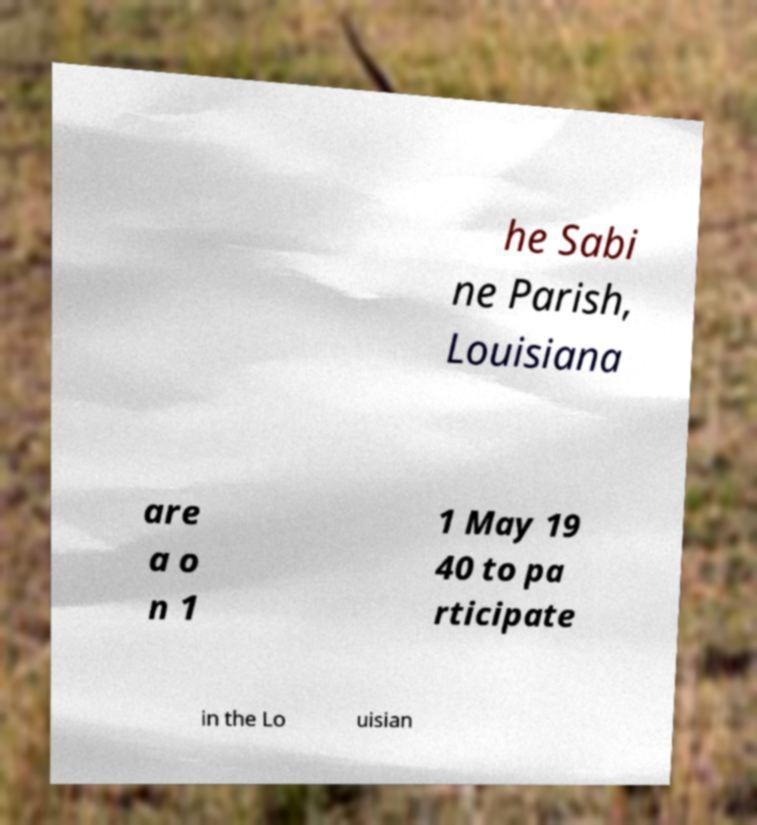Please identify and transcribe the text found in this image. he Sabi ne Parish, Louisiana are a o n 1 1 May 19 40 to pa rticipate in the Lo uisian 